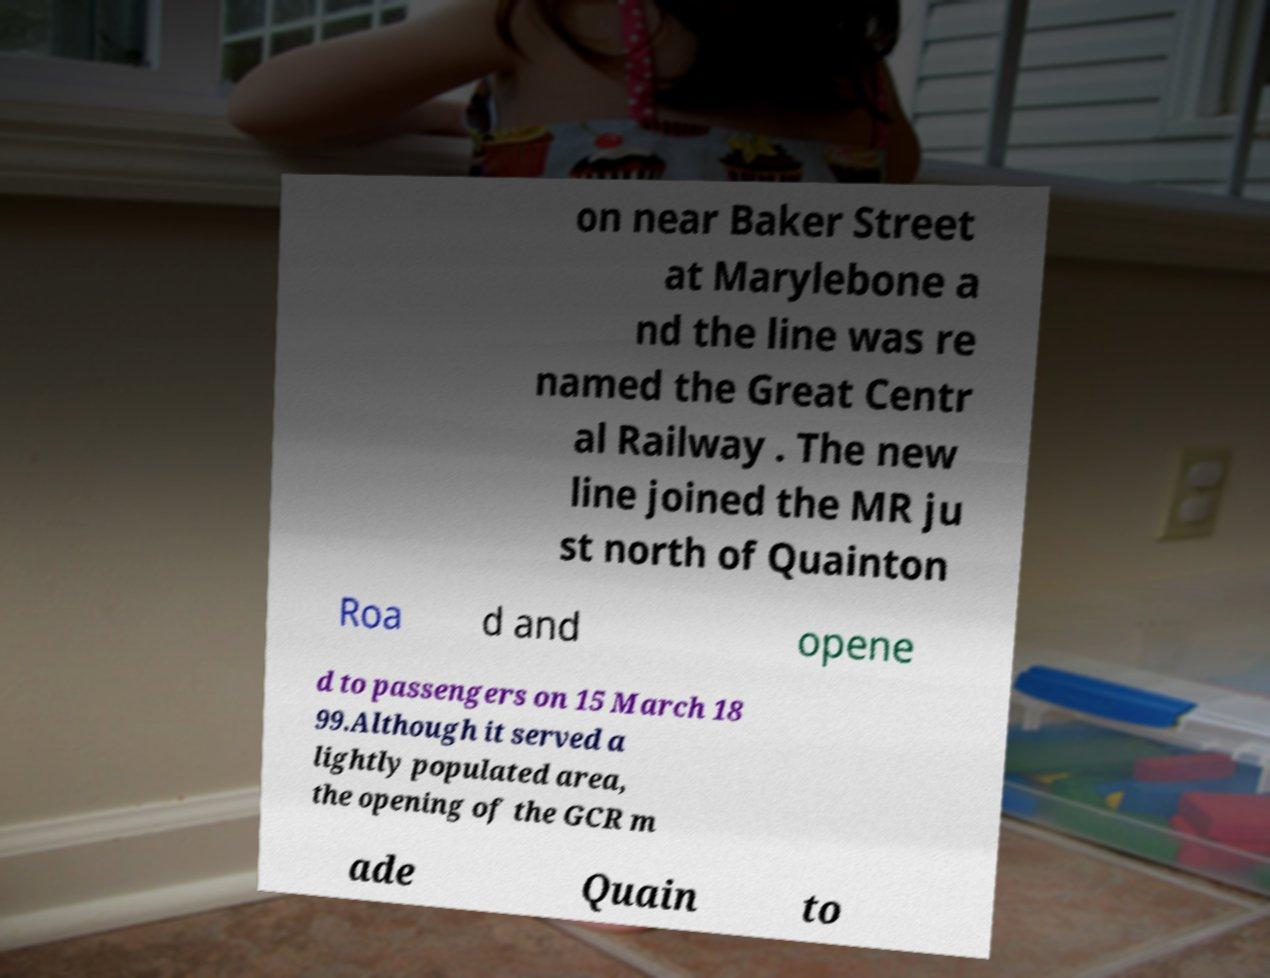For documentation purposes, I need the text within this image transcribed. Could you provide that? on near Baker Street at Marylebone a nd the line was re named the Great Centr al Railway . The new line joined the MR ju st north of Quainton Roa d and opene d to passengers on 15 March 18 99.Although it served a lightly populated area, the opening of the GCR m ade Quain to 